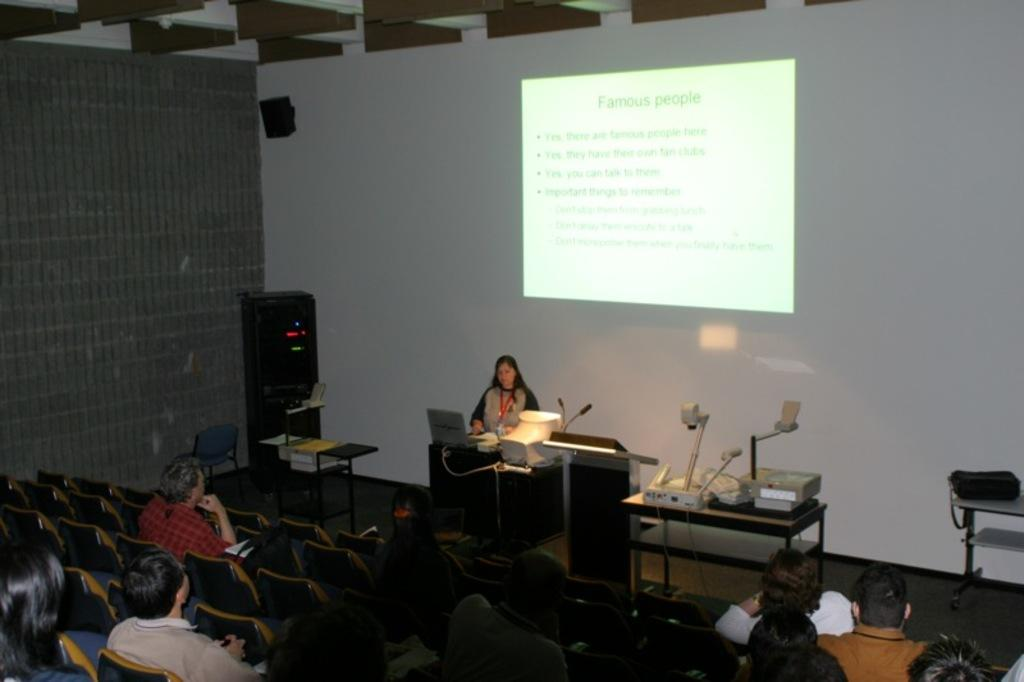Who is the main subject in the image? There is a lady in the image. What is the lady doing in the image? The lady is using a laptop. What can be seen in the background of the image? There is a screen in the background. What are the people in the image doing? The people are sitting on chairs and looking at the screen. How many bikes are parked next to the lady in the image? There are no bikes present in the image. Can you tell me the color of the locket the lady is wearing in the image? There is no locket visible on the lady in the image. 